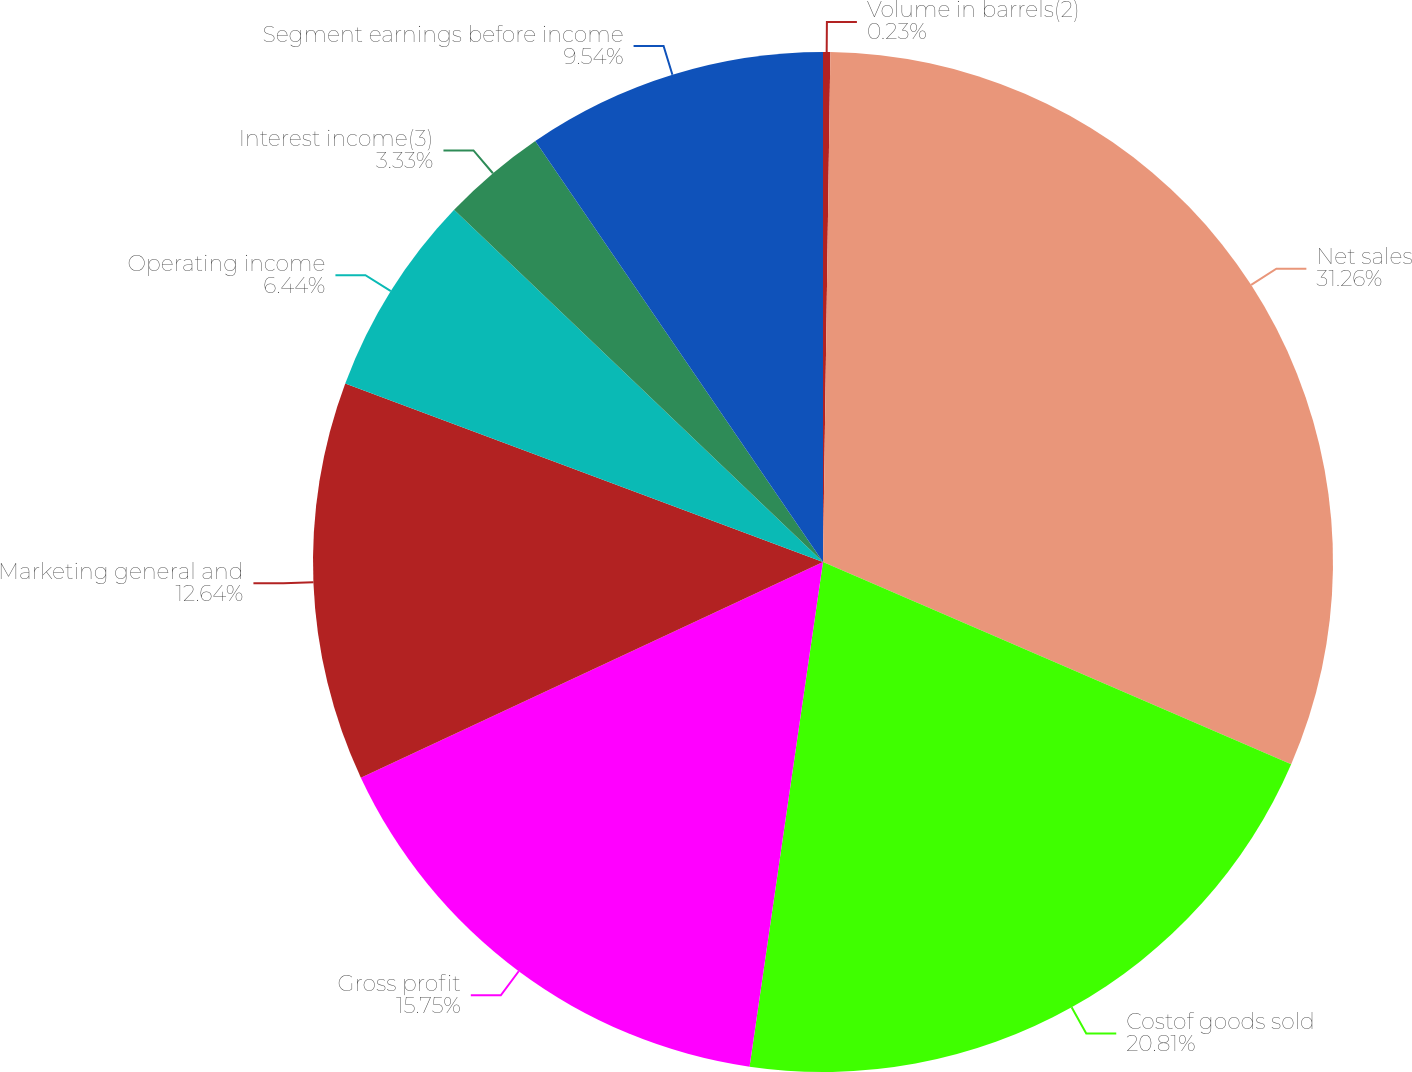<chart> <loc_0><loc_0><loc_500><loc_500><pie_chart><fcel>Volume in barrels(2)<fcel>Net sales<fcel>Costof goods sold<fcel>Gross profit<fcel>Marketing general and<fcel>Operating income<fcel>Interest income(3)<fcel>Segment earnings before income<nl><fcel>0.23%<fcel>31.26%<fcel>20.81%<fcel>15.75%<fcel>12.64%<fcel>6.44%<fcel>3.33%<fcel>9.54%<nl></chart> 